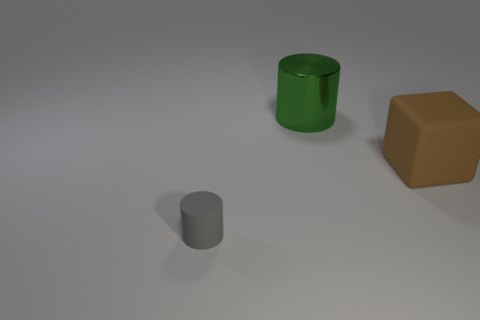Add 3 big green cylinders. How many objects exist? 6 Subtract 2 cylinders. How many cylinders are left? 0 Subtract all cubes. How many objects are left? 2 Add 1 blue matte spheres. How many blue matte spheres exist? 1 Subtract 0 purple cubes. How many objects are left? 3 Subtract all blue cylinders. Subtract all yellow cubes. How many cylinders are left? 2 Subtract all large purple metallic cylinders. Subtract all tiny things. How many objects are left? 2 Add 3 large green shiny cylinders. How many large green shiny cylinders are left? 4 